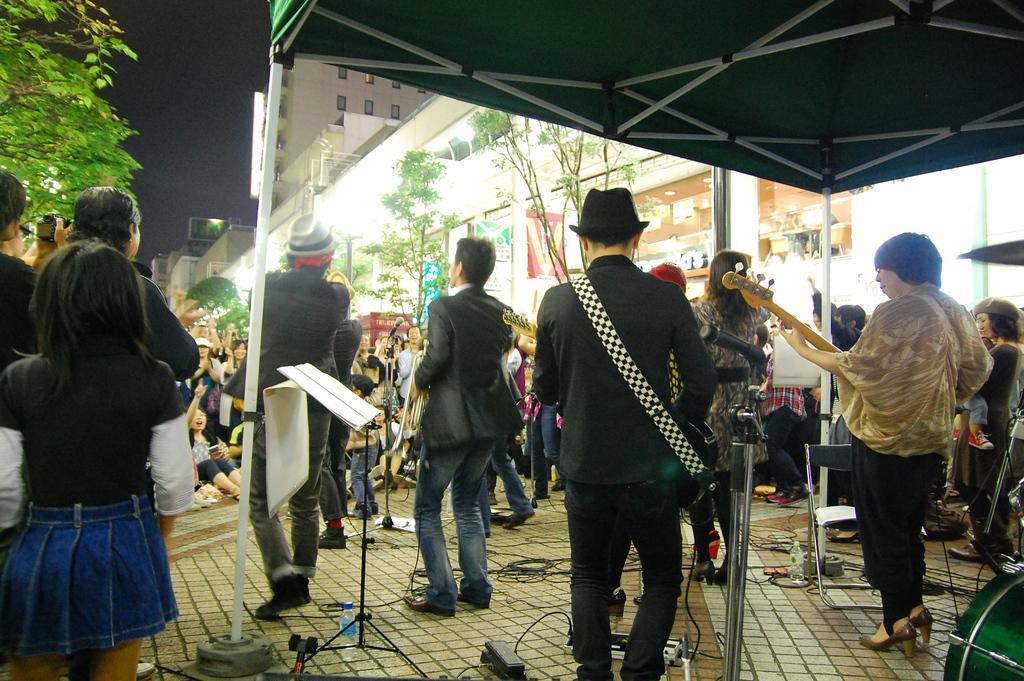In one or two sentences, can you explain what this image depicts? In this image we can see few people standing on the floor and few people standing under the tent, there are few mic´s, a book on the book stand, a bottle near the book sand, two persons are playing guitars, a person is holding camera, in the background there are building, boards, trees and the sky. 